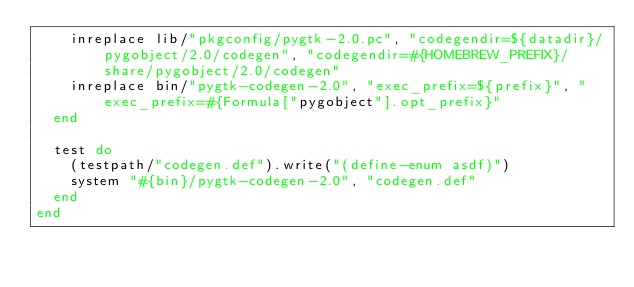Convert code to text. <code><loc_0><loc_0><loc_500><loc_500><_Ruby_>    inreplace lib/"pkgconfig/pygtk-2.0.pc", "codegendir=${datadir}/pygobject/2.0/codegen", "codegendir=#{HOMEBREW_PREFIX}/share/pygobject/2.0/codegen"
    inreplace bin/"pygtk-codegen-2.0", "exec_prefix=${prefix}", "exec_prefix=#{Formula["pygobject"].opt_prefix}"
  end

  test do
    (testpath/"codegen.def").write("(define-enum asdf)")
    system "#{bin}/pygtk-codegen-2.0", "codegen.def"
  end
end
</code> 